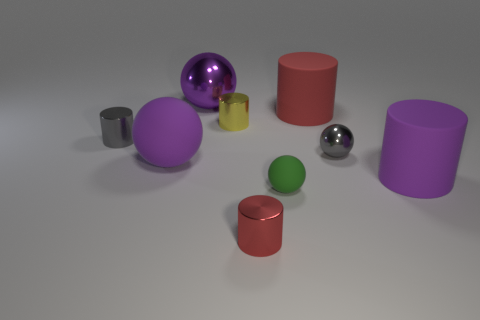There is a big matte thing that is the same color as the large matte ball; what is its shape?
Keep it short and to the point. Cylinder. What is the size of the purple metallic object behind the large red matte object right of the green ball?
Your response must be concise. Large. The metallic ball on the right side of the tiny red shiny cylinder is what color?
Give a very brief answer. Gray. Is there another matte object of the same shape as the big red rubber thing?
Your answer should be very brief. Yes. Is the number of tiny yellow objects on the left side of the red shiny object less than the number of shiny cylinders that are on the right side of the small gray metal cylinder?
Make the answer very short. Yes. What color is the big shiny thing?
Offer a very short reply. Purple. Is there a big purple cylinder that is in front of the tiny metal cylinder right of the yellow shiny cylinder?
Your response must be concise. No. What number of red cylinders are the same size as the purple metallic thing?
Make the answer very short. 1. How many big purple objects are right of the red object behind the tiny gray object that is right of the big metal thing?
Provide a short and direct response. 1. How many objects are both behind the large purple rubber sphere and left of the big shiny object?
Provide a short and direct response. 1. 